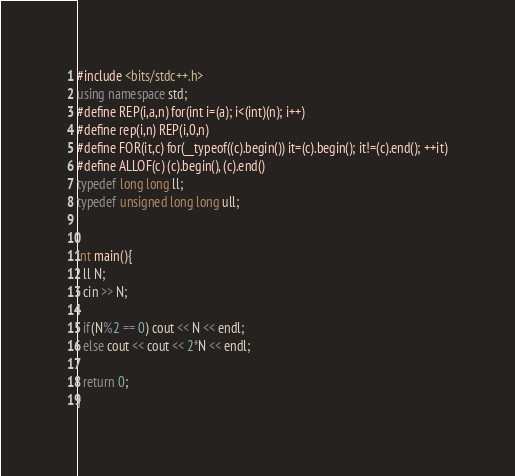<code> <loc_0><loc_0><loc_500><loc_500><_C++_>#include <bits/stdc++.h>
using namespace std;
#define REP(i,a,n) for(int i=(a); i<(int)(n); i++)
#define rep(i,n) REP(i,0,n)
#define FOR(it,c) for(__typeof((c).begin()) it=(c).begin(); it!=(c).end(); ++it)
#define ALLOF(c) (c).begin(), (c).end()
typedef long long ll;
typedef unsigned long long ull;


int main(){
  ll N;
  cin >> N;

  if(N%2 == 0) cout << N << endl;
  else cout << cout << 2*N << endl;
  
  return 0;
}
</code> 